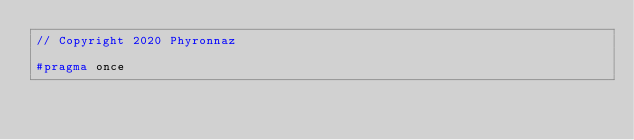<code> <loc_0><loc_0><loc_500><loc_500><_C_>// Copyright 2020 Phyronnaz

#pragma once
</code> 